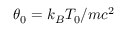Convert formula to latex. <formula><loc_0><loc_0><loc_500><loc_500>\theta _ { 0 } = k _ { B } T _ { 0 } / m c ^ { 2 }</formula> 